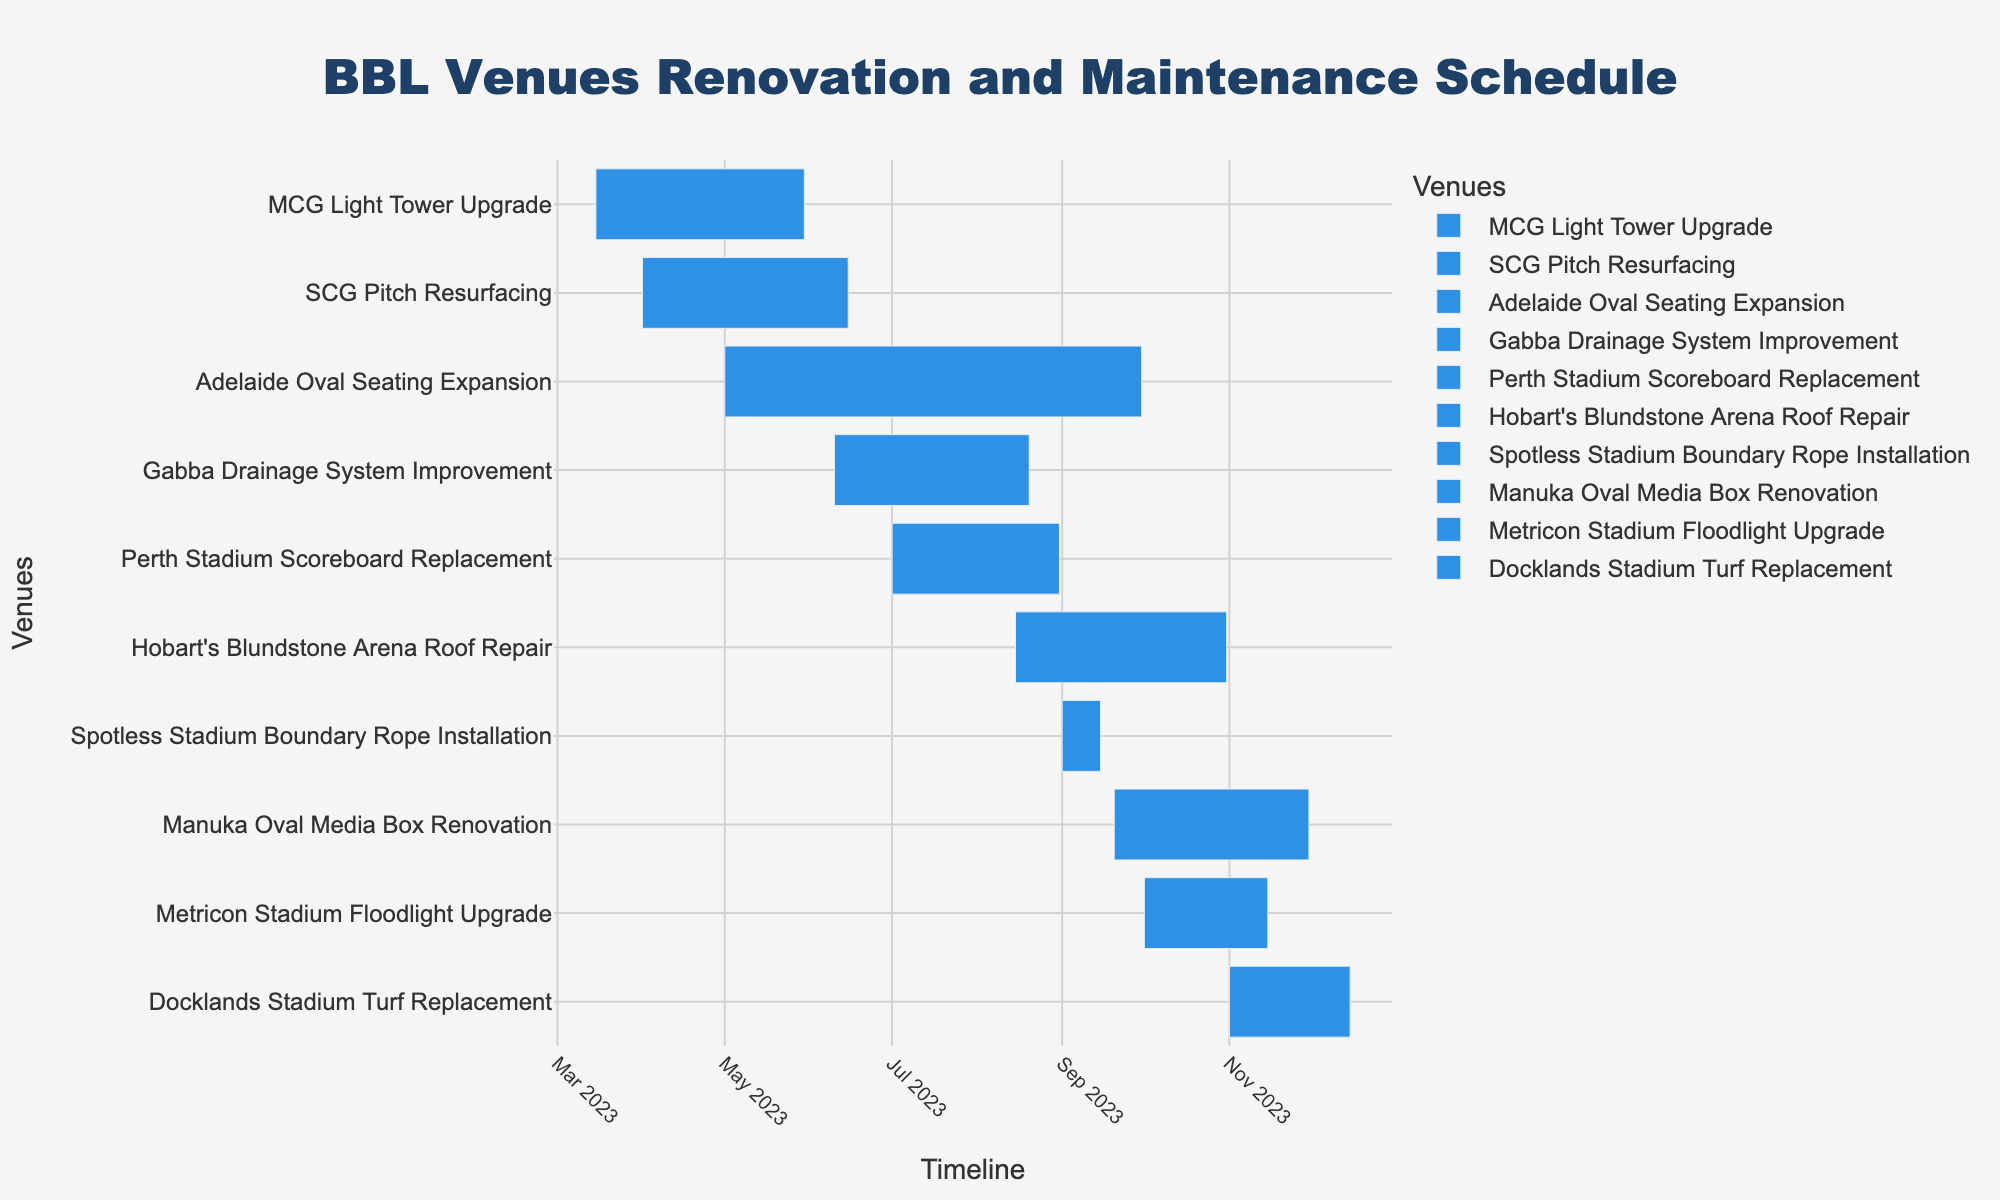What is the total duration for the MCG Light Tower Upgrade project? The chart shows the start date as March 15, 2023, and the end date as May 30, 2023. The total duration is the difference between these dates.
Answer: 76 days Which task is scheduled to start first? To determine the first task scheduled to start, look for the earliest start date on the chart.
Answer: MCG Light Tower Upgrade Which task finishes last? To identify the task that finishes last, locate the task with the latest end date on the chart.
Answer: Manuka Oval Media Box Renovation How many renovation tasks are scheduled to be conducted at the BBL venues? The number of renovation tasks can be counted from the chart by listing all the tasks.
Answer: 10 For how many days is the Perth Stadium Scoreboard Replacement scheduled? The chart shows the duration for Perth Stadium Scoreboard Replacement. This task is from July 1, 2023, to August 31, 2023. Calculate the number of days between these dates.
Answer: 62 days Which task has the shortest duration? Identify the task with the shortest bar on the chart. This corresponds to the task with the shortest duration.
Answer: Spotless Stadium Boundary Rope Installation How long does it take to complete both the Gabba and Adelaide Oval projects combined? Gabba Drainage System Improvement is scheduled from June 10, 2023, to August 20, 2023, which is 71 days. Adelaide Oval Seating Expansion runs from May 1, 2023, to September 30, 2023, which totals 153 days. Sum these durations to get the combined time.
Answer: 224 days Which tasks are scheduled to be ongoing concurrently in August 2023? Look for tasks that overlap within the month of August 2023.
Answer: Adelaide Oval Seating Expansion, Gabba Drainage System Improvement, and Perth Stadium Scoreboard Replacement How many days does the MCG Light Tower Upgrade finish before the SCG Pitch Resurfacing? The MCG Light Tower Upgrade ends on May 30, 2023, and the SCG Pitch Resurfacing ends on June 15, 2023. Calculate the number of days between these dates.
Answer: 16 days Name all projects starting in September 2023. Identify the tasks that have their start date within September 2023 on the chart.
Answer: Spotless Stadium Boundary Rope Installation and Manuka Oval Media Box Renovation 